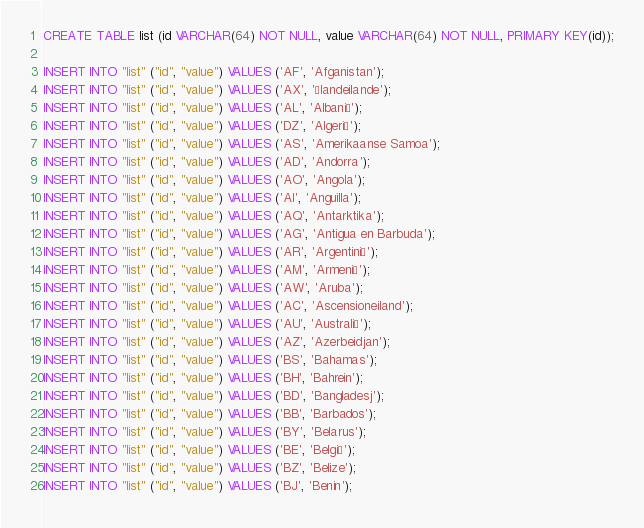<code> <loc_0><loc_0><loc_500><loc_500><_SQL_>CREATE TABLE list (id VARCHAR(64) NOT NULL, value VARCHAR(64) NOT NULL, PRIMARY KEY(id));

INSERT INTO "list" ("id", "value") VALUES ('AF', 'Afganistan');
INSERT INTO "list" ("id", "value") VALUES ('AX', 'Ålandeilande');
INSERT INTO "list" ("id", "value") VALUES ('AL', 'Albanië');
INSERT INTO "list" ("id", "value") VALUES ('DZ', 'Algerië');
INSERT INTO "list" ("id", "value") VALUES ('AS', 'Amerikaanse Samoa');
INSERT INTO "list" ("id", "value") VALUES ('AD', 'Andorra');
INSERT INTO "list" ("id", "value") VALUES ('AO', 'Angola');
INSERT INTO "list" ("id", "value") VALUES ('AI', 'Anguilla');
INSERT INTO "list" ("id", "value") VALUES ('AQ', 'Antarktika');
INSERT INTO "list" ("id", "value") VALUES ('AG', 'Antigua en Barbuda');
INSERT INTO "list" ("id", "value") VALUES ('AR', 'Argentinië');
INSERT INTO "list" ("id", "value") VALUES ('AM', 'Armenië');
INSERT INTO "list" ("id", "value") VALUES ('AW', 'Aruba');
INSERT INTO "list" ("id", "value") VALUES ('AC', 'Ascensioneiland');
INSERT INTO "list" ("id", "value") VALUES ('AU', 'Australië');
INSERT INTO "list" ("id", "value") VALUES ('AZ', 'Azerbeidjan');
INSERT INTO "list" ("id", "value") VALUES ('BS', 'Bahamas');
INSERT INTO "list" ("id", "value") VALUES ('BH', 'Bahrein');
INSERT INTO "list" ("id", "value") VALUES ('BD', 'Bangladesj');
INSERT INTO "list" ("id", "value") VALUES ('BB', 'Barbados');
INSERT INTO "list" ("id", "value") VALUES ('BY', 'Belarus');
INSERT INTO "list" ("id", "value") VALUES ('BE', 'België');
INSERT INTO "list" ("id", "value") VALUES ('BZ', 'Belize');
INSERT INTO "list" ("id", "value") VALUES ('BJ', 'Benin');</code> 